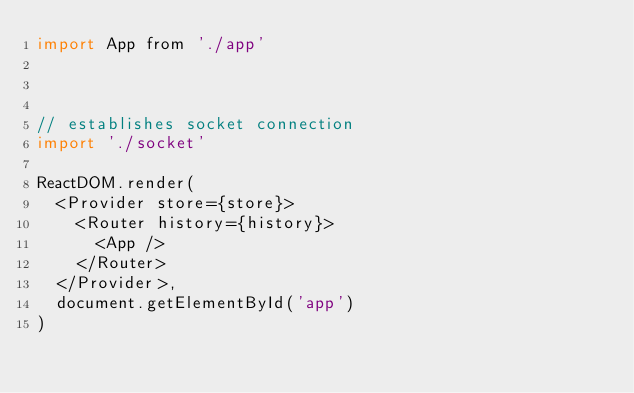Convert code to text. <code><loc_0><loc_0><loc_500><loc_500><_JavaScript_>import App from './app'



// establishes socket connection
import './socket'

ReactDOM.render(
  <Provider store={store}>
    <Router history={history}>
      <App />
    </Router>
  </Provider>,
  document.getElementById('app')
)
</code> 